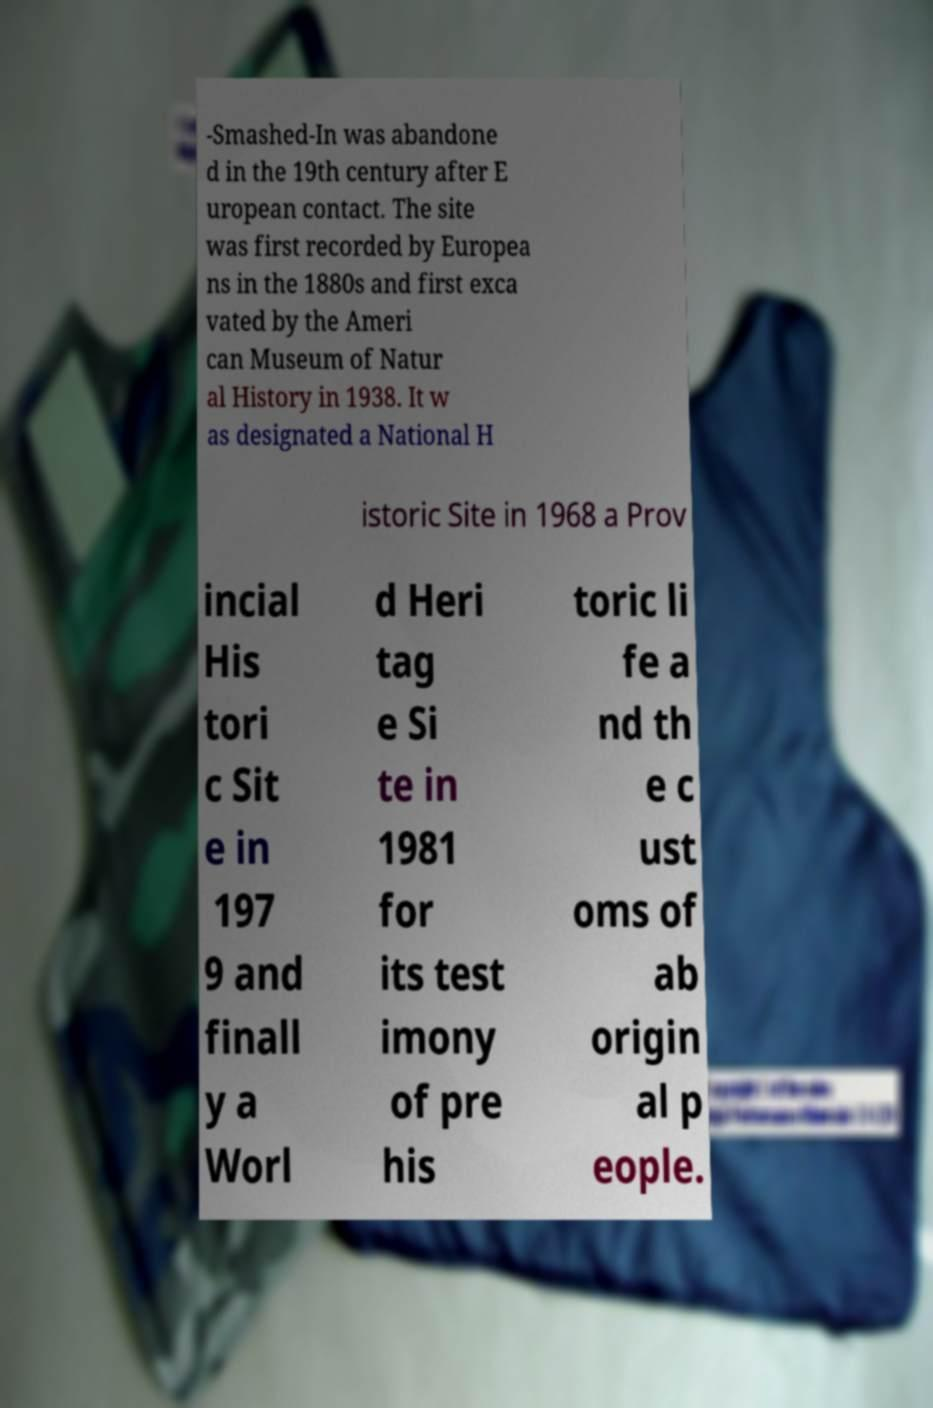Please read and relay the text visible in this image. What does it say? -Smashed-In was abandone d in the 19th century after E uropean contact. The site was first recorded by Europea ns in the 1880s and first exca vated by the Ameri can Museum of Natur al History in 1938. It w as designated a National H istoric Site in 1968 a Prov incial His tori c Sit e in 197 9 and finall y a Worl d Heri tag e Si te in 1981 for its test imony of pre his toric li fe a nd th e c ust oms of ab origin al p eople. 